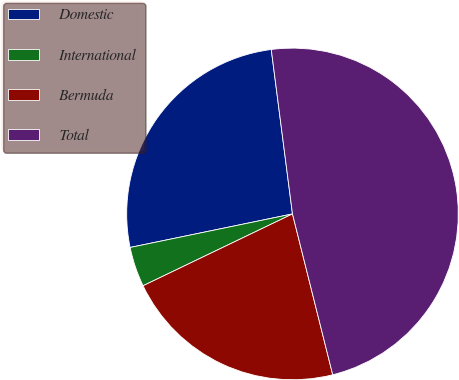<chart> <loc_0><loc_0><loc_500><loc_500><pie_chart><fcel>Domestic<fcel>International<fcel>Bermuda<fcel>Total<nl><fcel>26.2%<fcel>3.89%<fcel>21.77%<fcel>48.14%<nl></chart> 